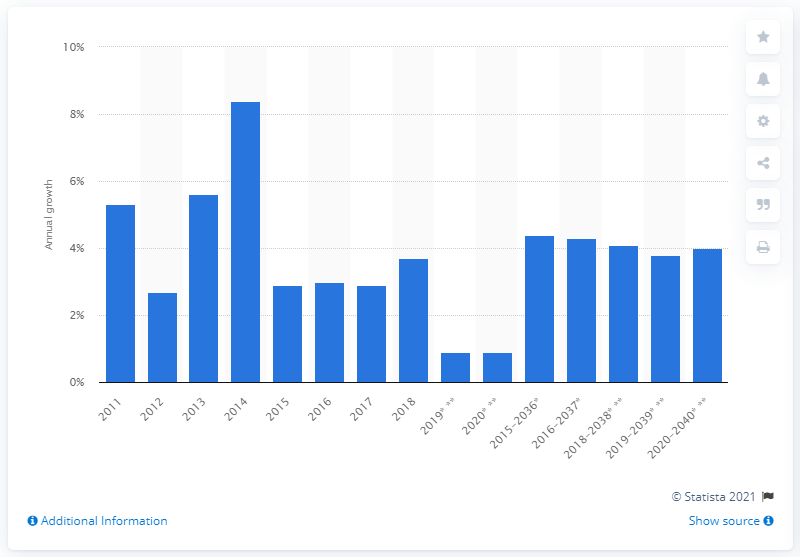List a handful of essential elements in this visual. According to projections, the annual growth of ASMs for the Latin market is expected to be approximately 4% between 2020 and 2040. 